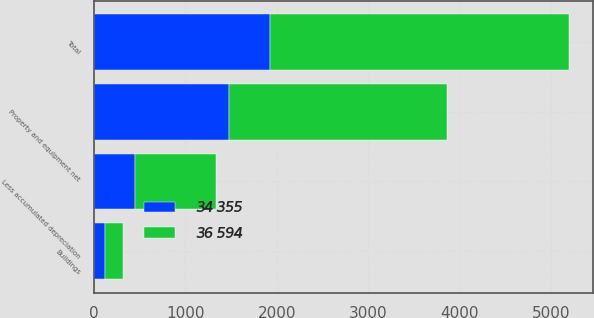Convert chart to OTSL. <chart><loc_0><loc_0><loc_500><loc_500><stacked_bar_chart><ecel><fcel>Buildings<fcel>Total<fcel>Less accumulated depreciation<fcel>Property and equipment net<nl><fcel>36 594<fcel>194<fcel>3273<fcel>882<fcel>2391<nl><fcel>34 355<fcel>120<fcel>1925<fcel>450<fcel>1475<nl></chart> 